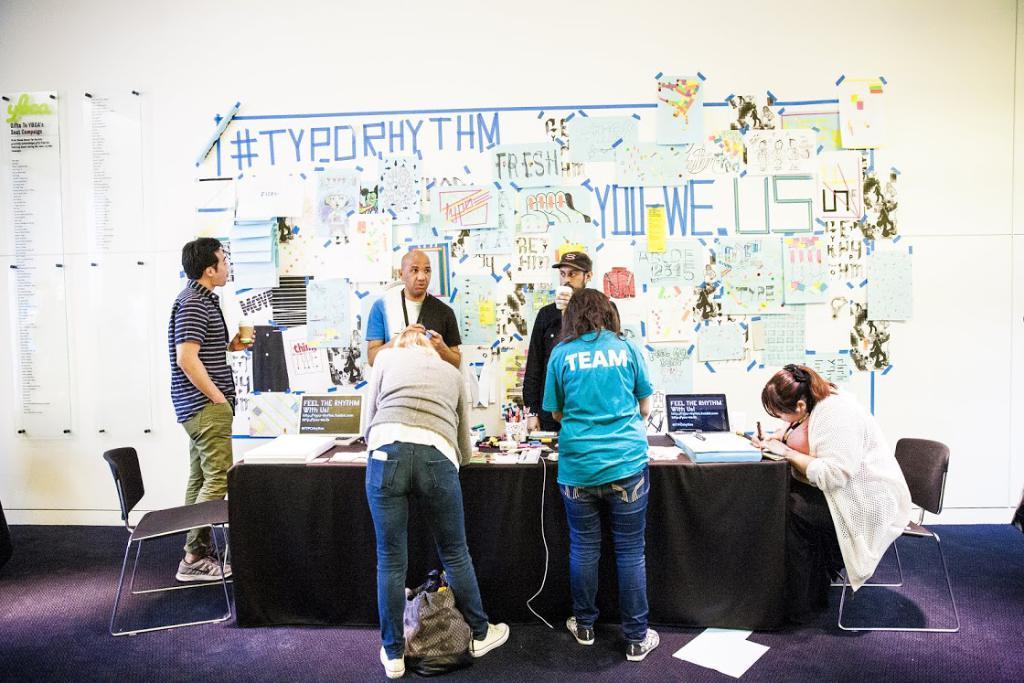Can you describe this image briefly? This is the picture where we have five people standing around the table and a lady sitting on table there are some things placed like laptops, pens, papers and some other things and to the other wall there is a things pasted with papers. 